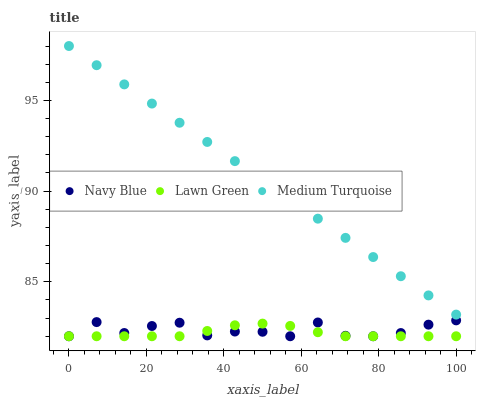Does Lawn Green have the minimum area under the curve?
Answer yes or no. Yes. Does Medium Turquoise have the maximum area under the curve?
Answer yes or no. Yes. Does Medium Turquoise have the minimum area under the curve?
Answer yes or no. No. Does Lawn Green have the maximum area under the curve?
Answer yes or no. No. Is Medium Turquoise the smoothest?
Answer yes or no. Yes. Is Navy Blue the roughest?
Answer yes or no. Yes. Is Lawn Green the smoothest?
Answer yes or no. No. Is Lawn Green the roughest?
Answer yes or no. No. Does Navy Blue have the lowest value?
Answer yes or no. Yes. Does Medium Turquoise have the lowest value?
Answer yes or no. No. Does Medium Turquoise have the highest value?
Answer yes or no. Yes. Does Lawn Green have the highest value?
Answer yes or no. No. Is Navy Blue less than Medium Turquoise?
Answer yes or no. Yes. Is Medium Turquoise greater than Lawn Green?
Answer yes or no. Yes. Does Lawn Green intersect Navy Blue?
Answer yes or no. Yes. Is Lawn Green less than Navy Blue?
Answer yes or no. No. Is Lawn Green greater than Navy Blue?
Answer yes or no. No. Does Navy Blue intersect Medium Turquoise?
Answer yes or no. No. 